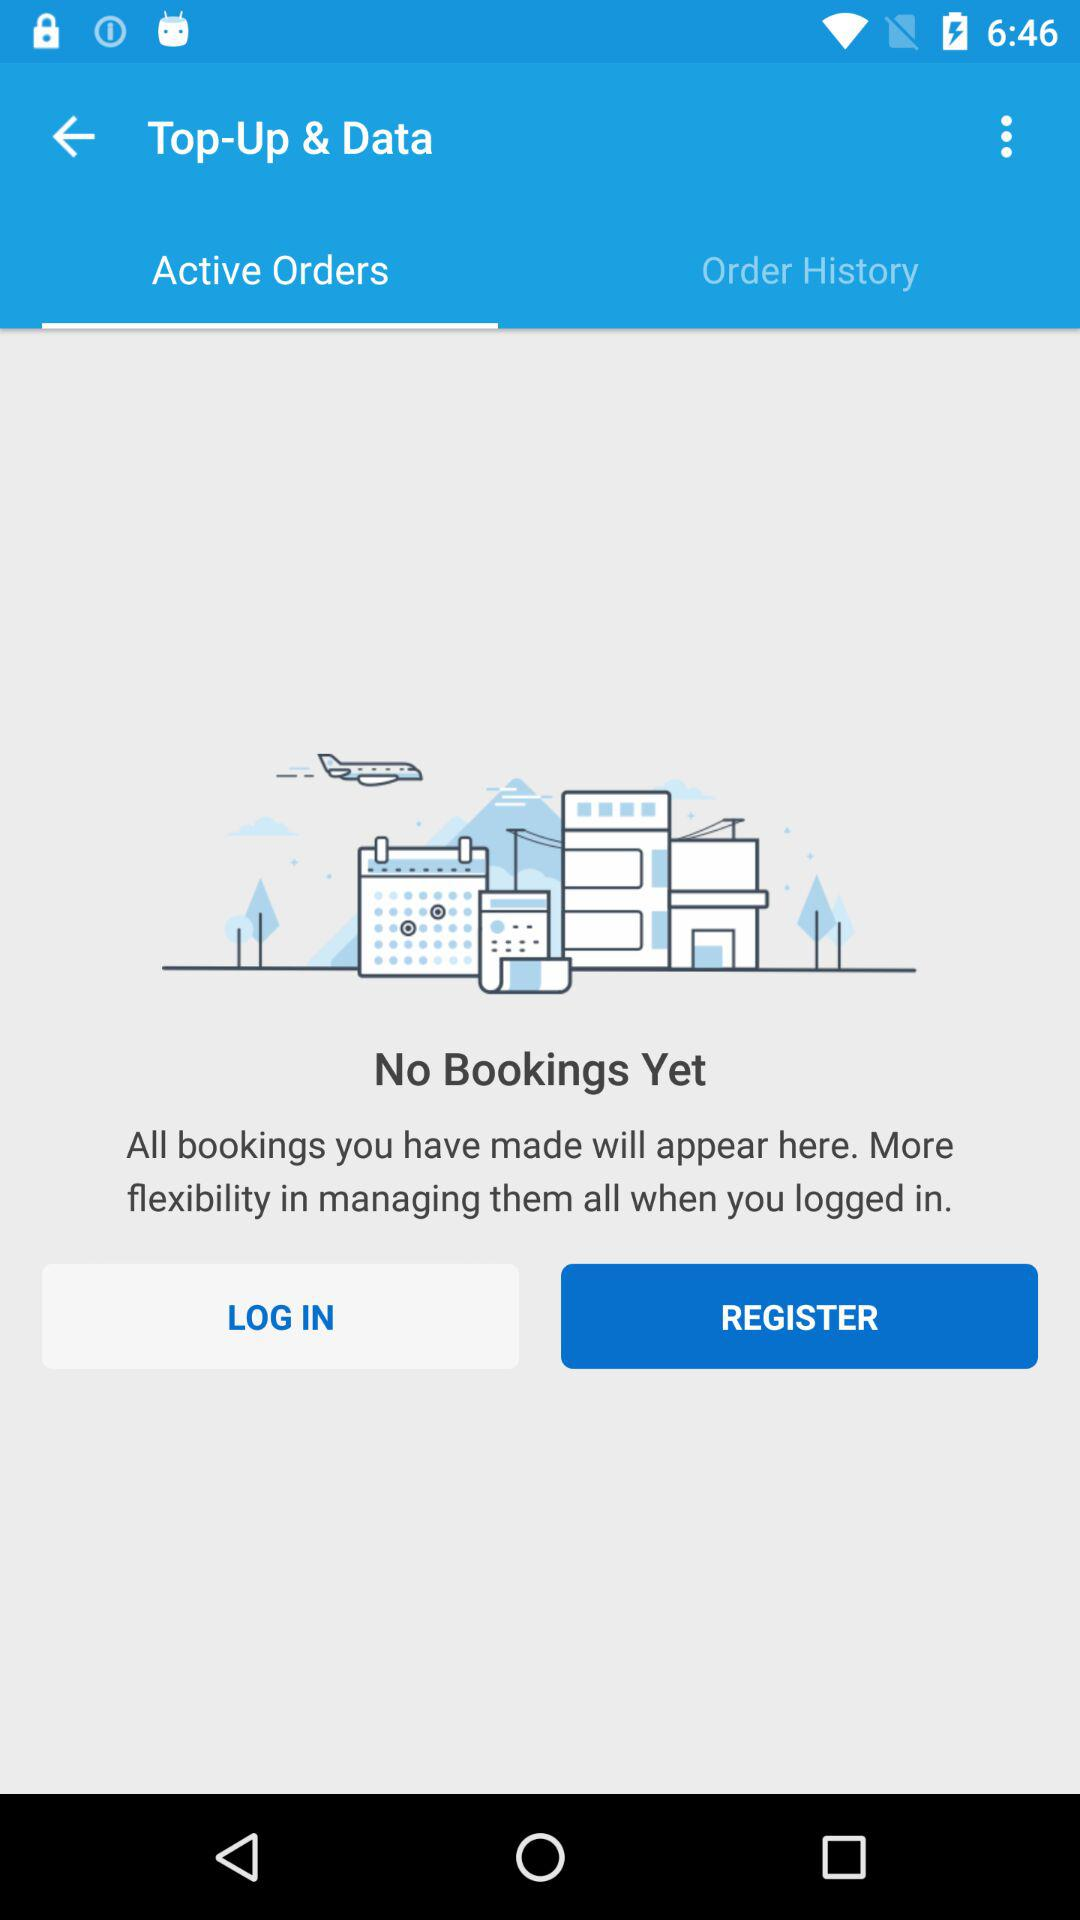Is there any booking? There is no booking. 